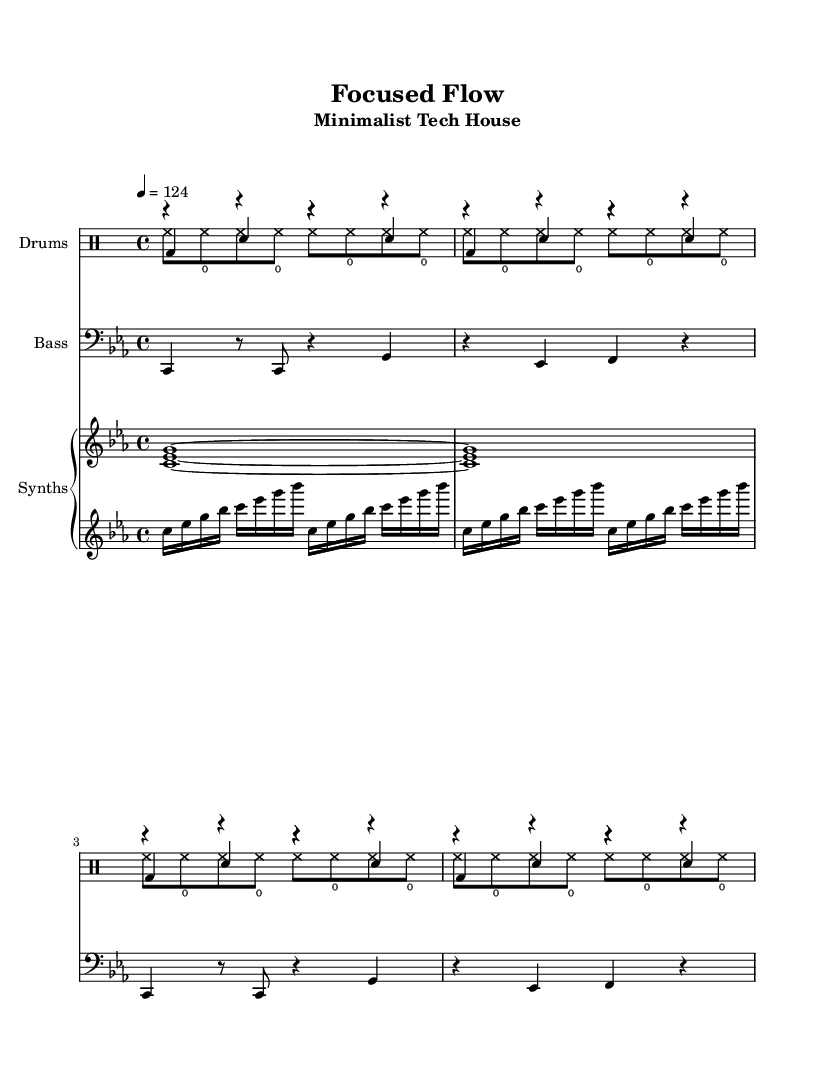What is the key signature of this music? The key signature in the music is indicated by the key section at the beginning. It shows C minor, which has three flats (B flat, E flat, and A flat).
Answer: C minor What is the time signature of this music? The time signature is found at the beginning of the sheet music, which indicates how many beats are in each measure. Here, it shows 4/4 time, meaning there are four beats per measure.
Answer: 4/4 What is the tempo marking of this piece? The tempo marking is found in the tempo section that specifies the beats per minute. In this music, it is marked as a quarter note equals 124 beats per minute.
Answer: 124 How many measures are in the kick drum pattern? The kick drum pattern is repeated four times, and each repetition consists of one measure. Thus, the total number of measures in the kick drum pattern is four.
Answer: 4 What kind of ensemble is this score written for? The score is structured into different instrument voices, including a DrumStaff, a Bass Staff, and a PianoStaff, indicating it is meant for a small ensemble with rhythmic and melodic components.
Answer: Small ensemble How does the bassline evolve throughout the piece? Looking at the bassline, it consists of repeated phrases that vary in duration and pitch. The line changes pitches, alternating between two notes across the measures, giving it a subtle evolution while maintaining focus.
Answer: Evolving bassline What rhythmic element is prominent in the hihat section? The hihat section is characterized by a repeating pattern that creates a steady pulse. It has a consistent sixteenth note rhythm, creating a driving and continuous sound typical in tech house music.
Answer: Sixteenth notes 